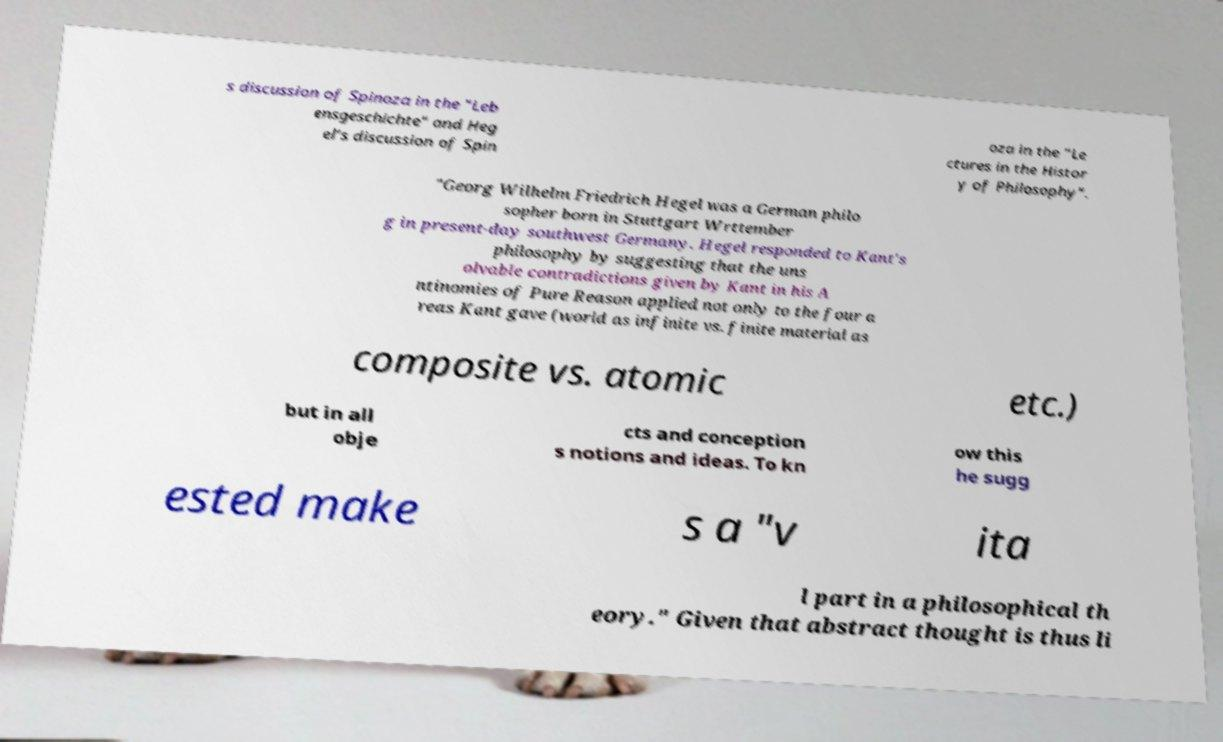What messages or text are displayed in this image? I need them in a readable, typed format. s discussion of Spinoza in the "Leb ensgeschichte" and Heg el’s discussion of Spin oza in the "Le ctures in the Histor y of Philosophy". "Georg Wilhelm Friedrich Hegel was a German philo sopher born in Stuttgart Wrttember g in present-day southwest Germany. Hegel responded to Kant's philosophy by suggesting that the uns olvable contradictions given by Kant in his A ntinomies of Pure Reason applied not only to the four a reas Kant gave (world as infinite vs. finite material as composite vs. atomic etc.) but in all obje cts and conception s notions and ideas. To kn ow this he sugg ested make s a "v ita l part in a philosophical th eory." Given that abstract thought is thus li 